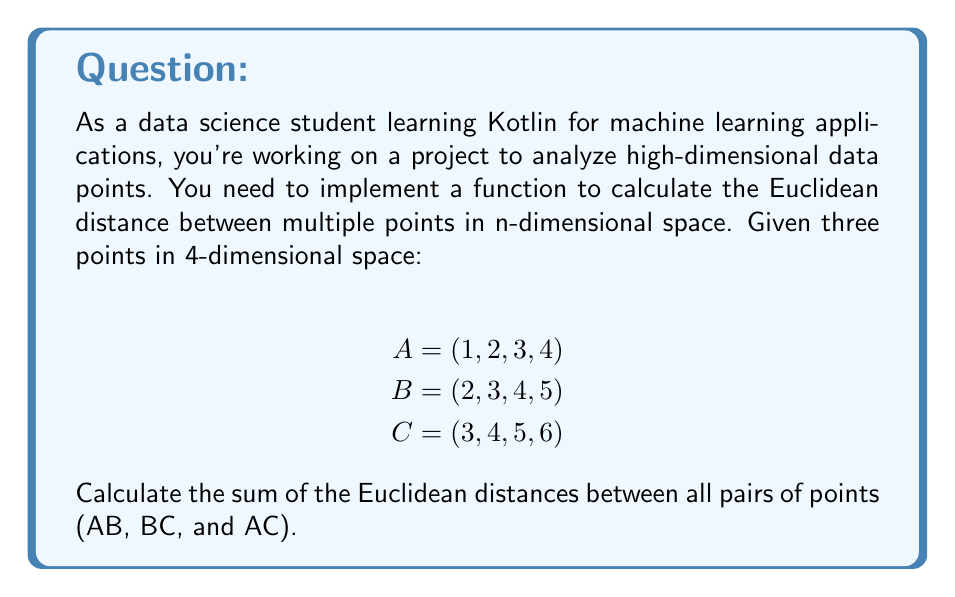Provide a solution to this math problem. To solve this problem, we'll follow these steps:

1. Calculate the Euclidean distance between each pair of points.
2. Sum up all the calculated distances.

The Euclidean distance between two points in n-dimensional space is given by the formula:

$$d = \sqrt{\sum_{i=1}^n (x_i - y_i)^2}$$

Where $x_i$ and $y_i$ are the coordinates of the two points in the $i$-th dimension.

Let's calculate the distance for each pair:

1. Distance between A and B:
   $$\begin{align}
   d_{AB} &= \sqrt{(2-1)^2 + (3-2)^2 + (4-3)^2 + (5-4)^2} \\
   &= \sqrt{1^2 + 1^2 + 1^2 + 1^2} \\
   &= \sqrt{4} \\
   &= 2
   \end{align}$$

2. Distance between B and C:
   $$\begin{align}
   d_{BC} &= \sqrt{(3-2)^2 + (4-3)^2 + (5-4)^2 + (6-5)^2} \\
   &= \sqrt{1^2 + 1^2 + 1^2 + 1^2} \\
   &= \sqrt{4} \\
   &= 2
   \end{align}$$

3. Distance between A and C:
   $$\begin{align}
   d_{AC} &= \sqrt{(3-1)^2 + (4-2)^2 + (5-3)^2 + (6-4)^2} \\
   &= \sqrt{2^2 + 2^2 + 2^2 + 2^2} \\
   &= \sqrt{16} \\
   &= 4
   \end{align}$$

Now, we sum up all the calculated distances:

$$\text{Total distance} = d_{AB} + d_{BC} + d_{AC} = 2 + 2 + 4 = 8$$
Answer: The sum of the Euclidean distances between all pairs of points is 8. 